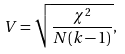<formula> <loc_0><loc_0><loc_500><loc_500>V = { \sqrt { \frac { \chi ^ { 2 } } { N ( k - 1 ) } } } ,</formula> 